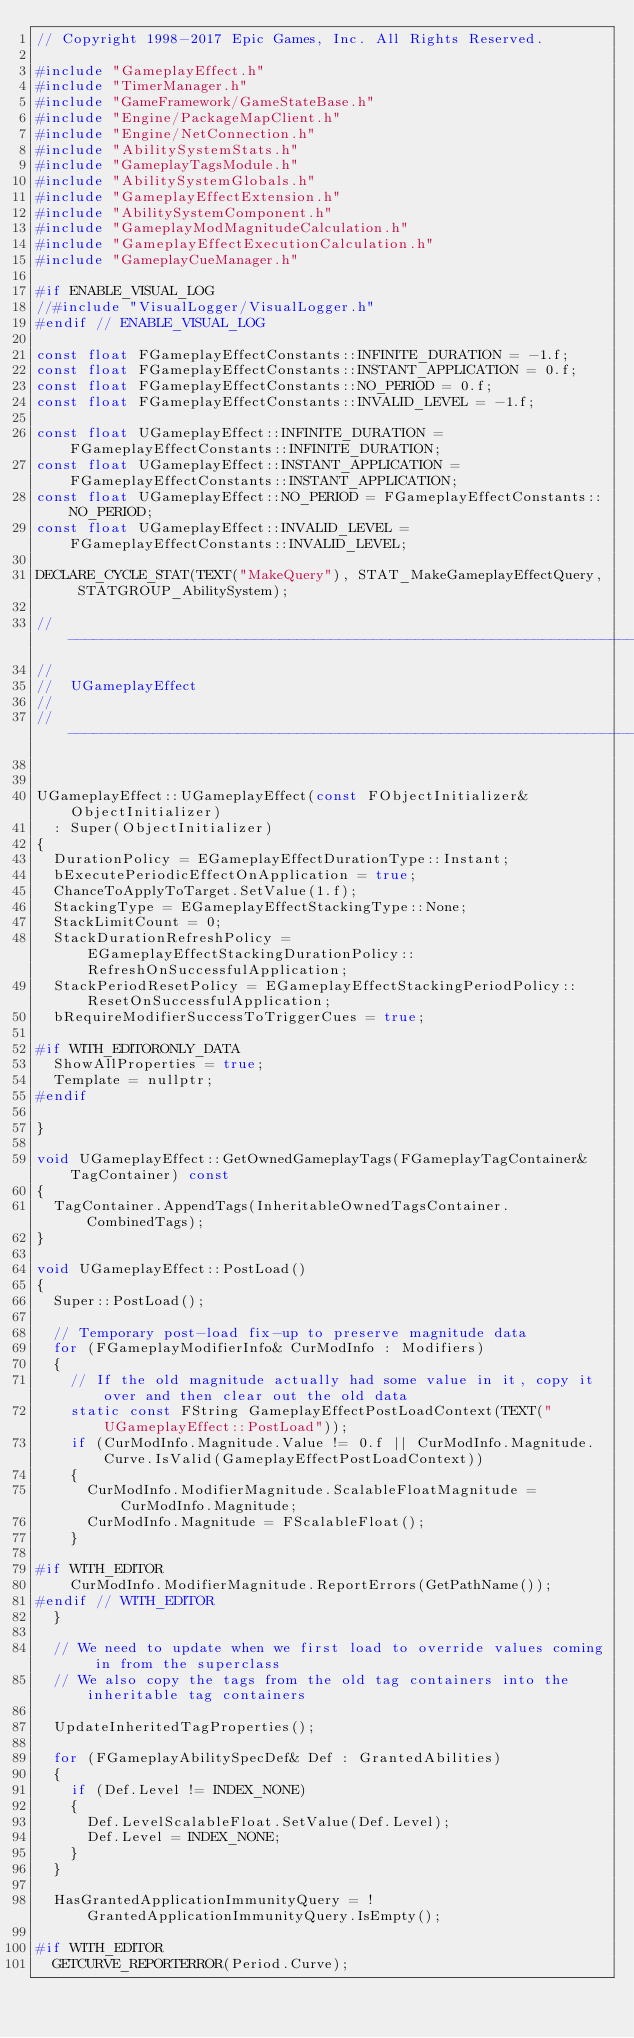Convert code to text. <code><loc_0><loc_0><loc_500><loc_500><_C++_>// Copyright 1998-2017 Epic Games, Inc. All Rights Reserved.

#include "GameplayEffect.h"
#include "TimerManager.h"
#include "GameFramework/GameStateBase.h"
#include "Engine/PackageMapClient.h"
#include "Engine/NetConnection.h"
#include "AbilitySystemStats.h"
#include "GameplayTagsModule.h"
#include "AbilitySystemGlobals.h"
#include "GameplayEffectExtension.h"
#include "AbilitySystemComponent.h"
#include "GameplayModMagnitudeCalculation.h"
#include "GameplayEffectExecutionCalculation.h"
#include "GameplayCueManager.h"

#if ENABLE_VISUAL_LOG
//#include "VisualLogger/VisualLogger.h"
#endif // ENABLE_VISUAL_LOG

const float FGameplayEffectConstants::INFINITE_DURATION = -1.f;
const float FGameplayEffectConstants::INSTANT_APPLICATION = 0.f;
const float FGameplayEffectConstants::NO_PERIOD = 0.f;
const float FGameplayEffectConstants::INVALID_LEVEL = -1.f;

const float UGameplayEffect::INFINITE_DURATION = FGameplayEffectConstants::INFINITE_DURATION;
const float UGameplayEffect::INSTANT_APPLICATION =FGameplayEffectConstants::INSTANT_APPLICATION;
const float UGameplayEffect::NO_PERIOD = FGameplayEffectConstants::NO_PERIOD;
const float UGameplayEffect::INVALID_LEVEL = FGameplayEffectConstants::INVALID_LEVEL;

DECLARE_CYCLE_STAT(TEXT("MakeQuery"), STAT_MakeGameplayEffectQuery, STATGROUP_AbilitySystem);

// --------------------------------------------------------------------------------------------------------------------------------------------------------
//
//	UGameplayEffect
//
// --------------------------------------------------------------------------------------------------------------------------------------------------------


UGameplayEffect::UGameplayEffect(const FObjectInitializer& ObjectInitializer)
	: Super(ObjectInitializer)
{
	DurationPolicy = EGameplayEffectDurationType::Instant;
	bExecutePeriodicEffectOnApplication = true;
	ChanceToApplyToTarget.SetValue(1.f);
	StackingType = EGameplayEffectStackingType::None;
	StackLimitCount = 0;
	StackDurationRefreshPolicy = EGameplayEffectStackingDurationPolicy::RefreshOnSuccessfulApplication;
	StackPeriodResetPolicy = EGameplayEffectStackingPeriodPolicy::ResetOnSuccessfulApplication;
	bRequireModifierSuccessToTriggerCues = true;

#if WITH_EDITORONLY_DATA
	ShowAllProperties = true;
	Template = nullptr;
#endif

}

void UGameplayEffect::GetOwnedGameplayTags(FGameplayTagContainer& TagContainer) const
{
	TagContainer.AppendTags(InheritableOwnedTagsContainer.CombinedTags);
}

void UGameplayEffect::PostLoad()
{
	Super::PostLoad();

	// Temporary post-load fix-up to preserve magnitude data
	for (FGameplayModifierInfo& CurModInfo : Modifiers)
	{
		// If the old magnitude actually had some value in it, copy it over and then clear out the old data
		static const FString GameplayEffectPostLoadContext(TEXT("UGameplayEffect::PostLoad"));
		if (CurModInfo.Magnitude.Value != 0.f || CurModInfo.Magnitude.Curve.IsValid(GameplayEffectPostLoadContext))
		{
			CurModInfo.ModifierMagnitude.ScalableFloatMagnitude = CurModInfo.Magnitude;
			CurModInfo.Magnitude = FScalableFloat();
		}

#if WITH_EDITOR
		CurModInfo.ModifierMagnitude.ReportErrors(GetPathName());
#endif // WITH_EDITOR
	}

	// We need to update when we first load to override values coming in from the superclass
	// We also copy the tags from the old tag containers into the inheritable tag containers

	UpdateInheritedTagProperties();

	for (FGameplayAbilitySpecDef& Def : GrantedAbilities)
	{
		if (Def.Level != INDEX_NONE)
		{
			Def.LevelScalableFloat.SetValue(Def.Level);
			Def.Level = INDEX_NONE;
		}
	}

	HasGrantedApplicationImmunityQuery = !GrantedApplicationImmunityQuery.IsEmpty();

#if WITH_EDITOR
	GETCURVE_REPORTERROR(Period.Curve);</code> 